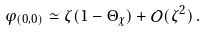<formula> <loc_0><loc_0><loc_500><loc_500>\varphi _ { ( 0 , 0 ) } \simeq \zeta ( 1 - \Theta _ { \chi } ) + \mathcal { O } ( \zeta ^ { 2 } ) \, .</formula> 